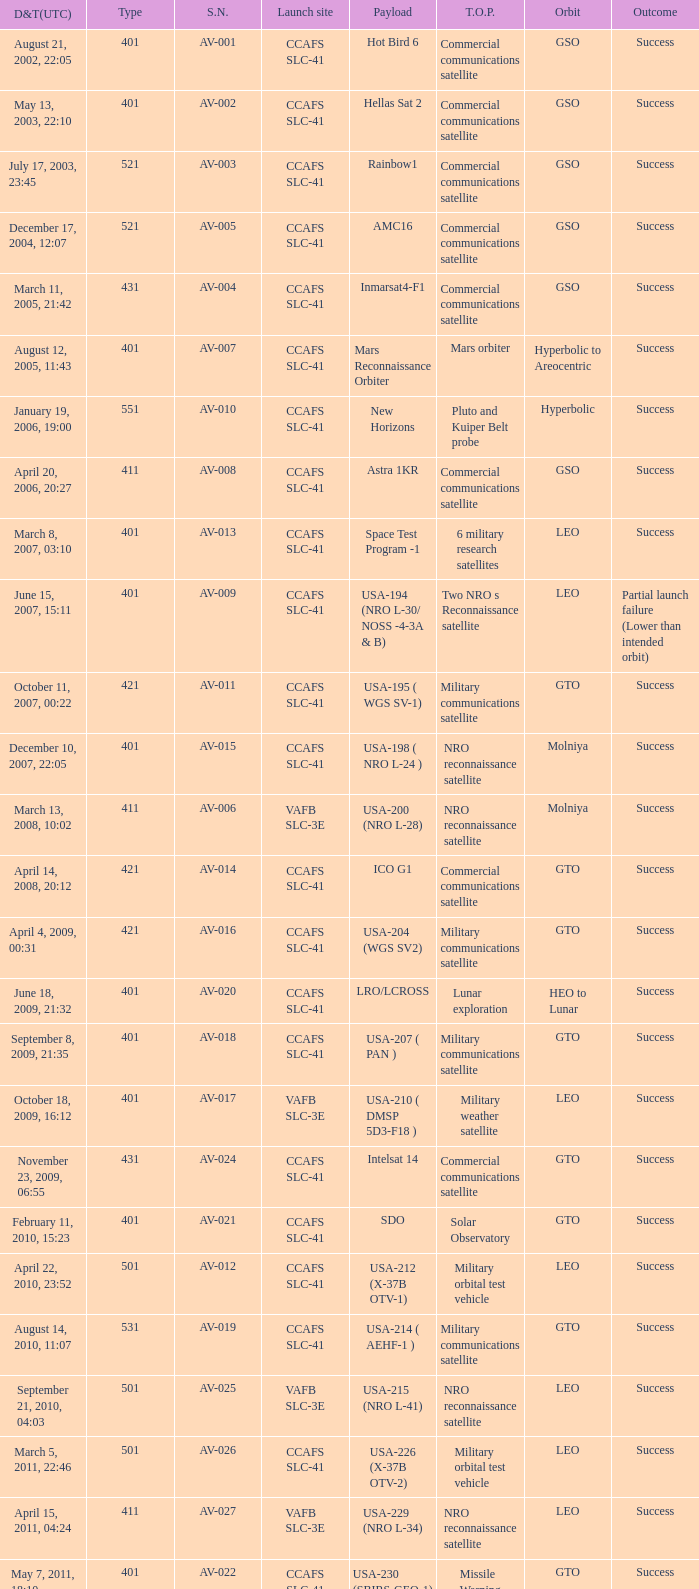When was the payload of Commercial Communications Satellite amc16? December 17, 2004, 12:07. 